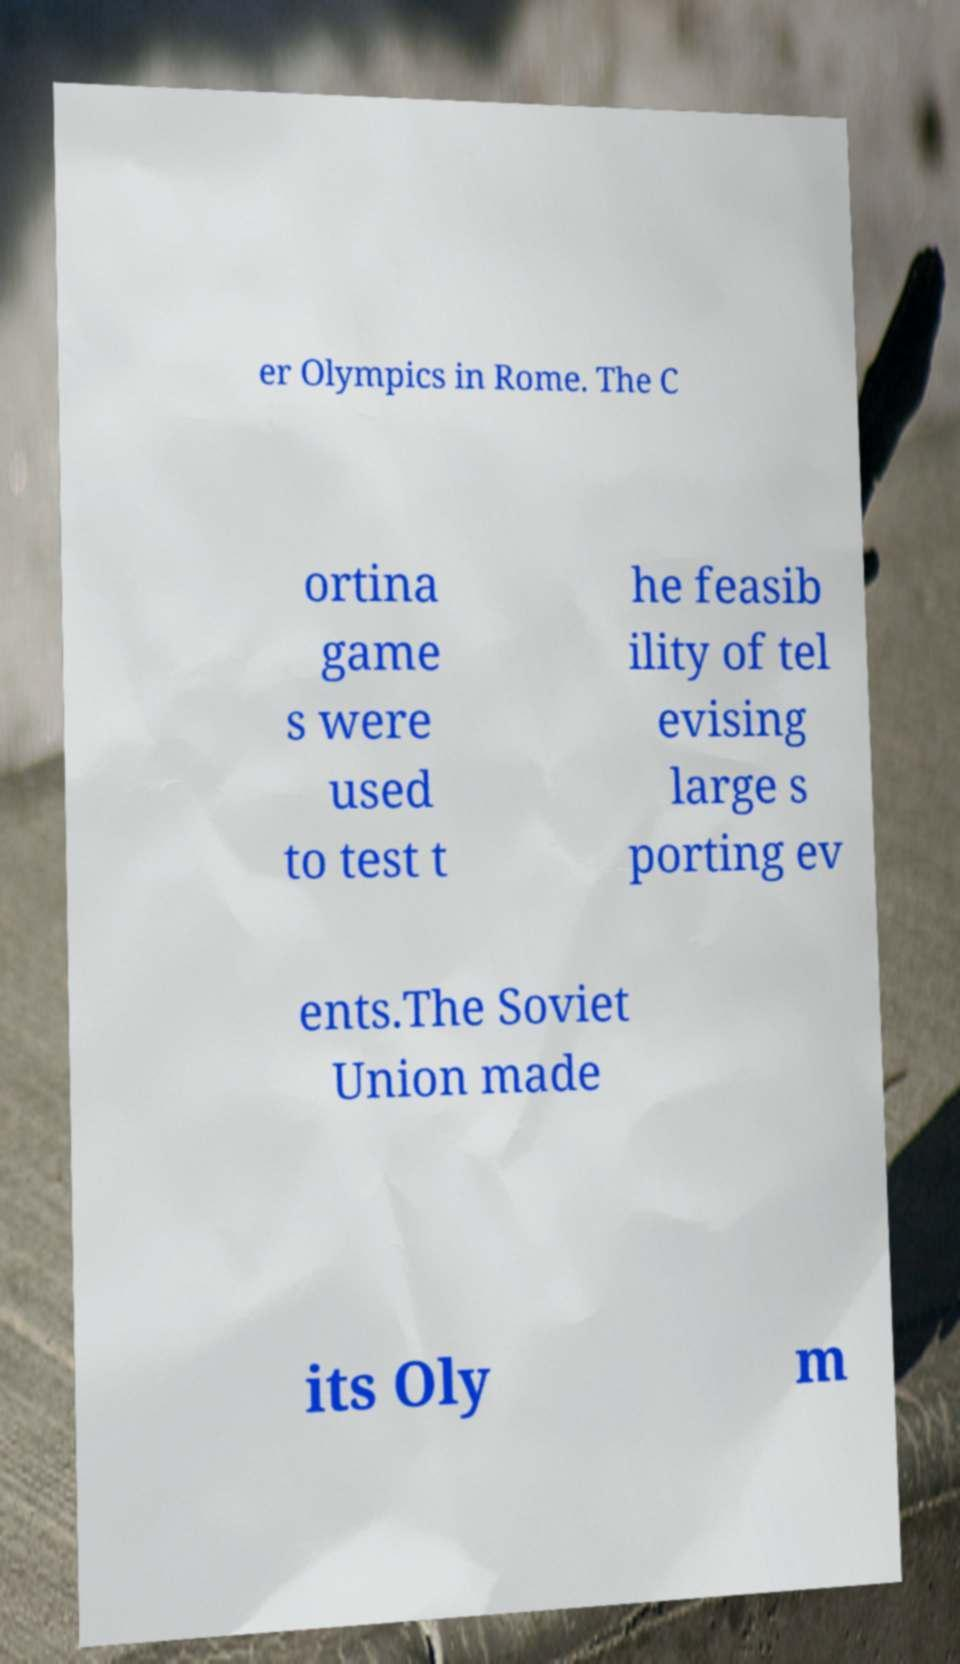What messages or text are displayed in this image? I need them in a readable, typed format. er Olympics in Rome. The C ortina game s were used to test t he feasib ility of tel evising large s porting ev ents.The Soviet Union made its Oly m 